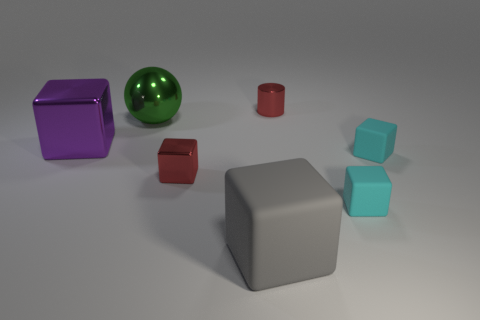How many other things are there of the same shape as the gray rubber thing?
Keep it short and to the point. 4. What number of green things are large objects or metal cylinders?
Your answer should be very brief. 1. Is the shape of the green thing the same as the gray thing?
Make the answer very short. No. There is a big block right of the red block; are there any metal spheres that are to the right of it?
Make the answer very short. No. Are there the same number of objects that are behind the purple cube and large cyan matte things?
Your answer should be compact. No. What number of other things are there of the same size as the metal ball?
Your response must be concise. 2. Does the big ball that is left of the red shiny cube have the same material as the large cube behind the gray rubber block?
Keep it short and to the point. Yes. There is a cylinder that is right of the large block that is behind the big rubber cube; what size is it?
Ensure brevity in your answer.  Small. Are there any other large spheres of the same color as the big ball?
Keep it short and to the point. No. There is a metallic object that is behind the large green metallic ball; is it the same color as the small block to the left of the red cylinder?
Provide a short and direct response. Yes. 